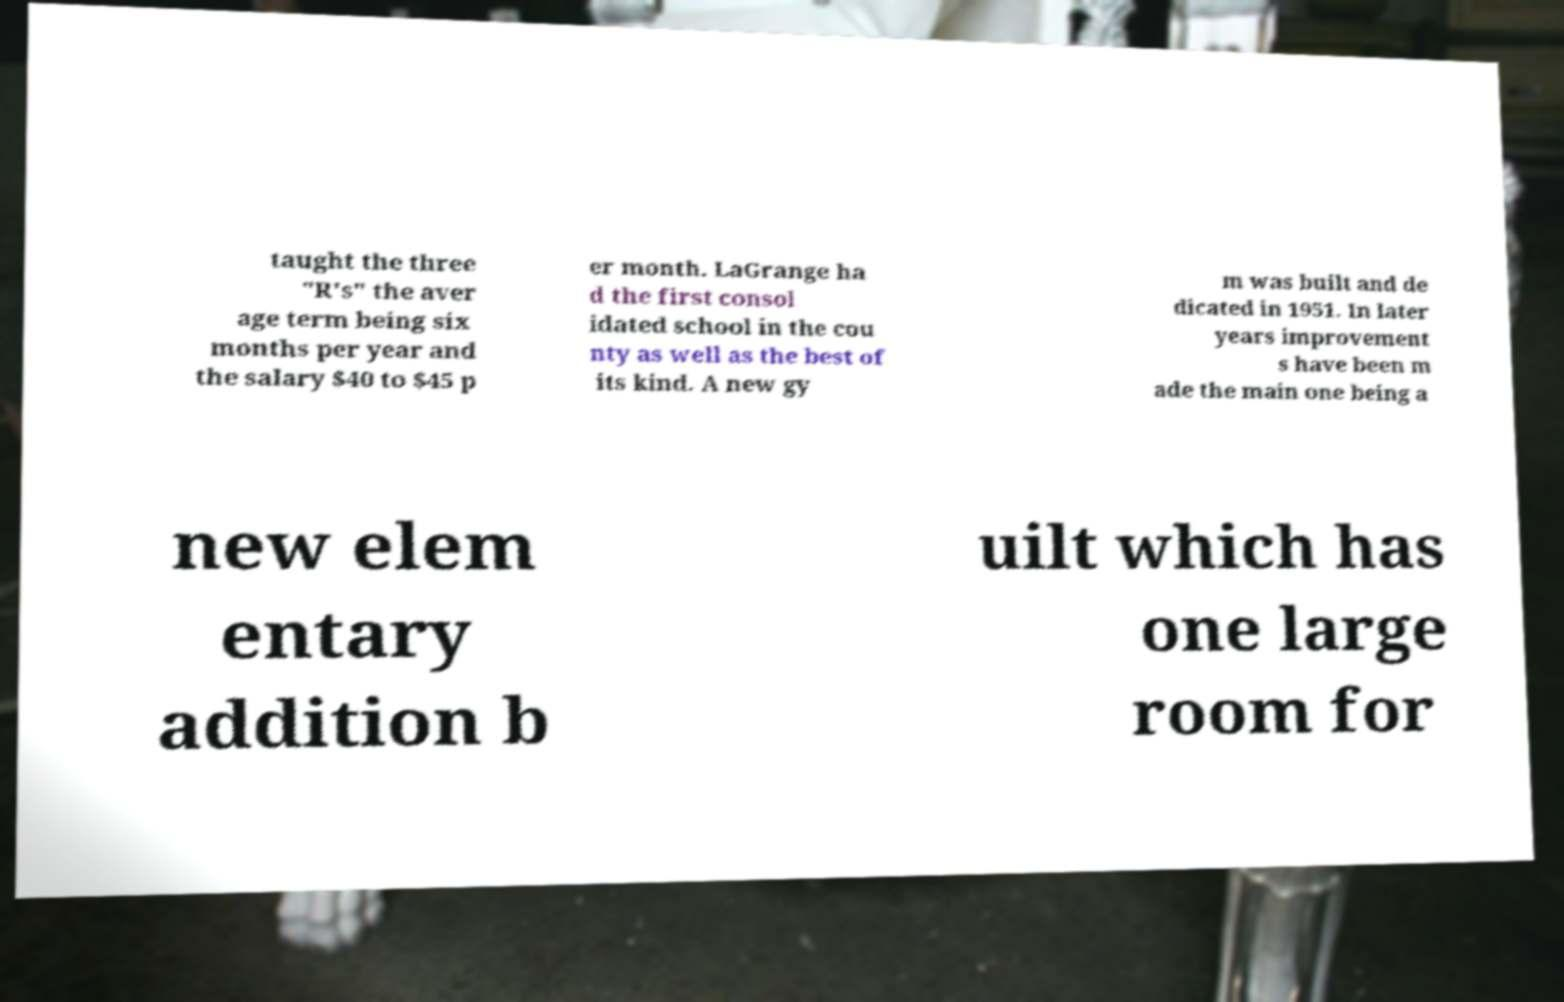Could you extract and type out the text from this image? taught the three "R's" the aver age term being six months per year and the salary $40 to $45 p er month. LaGrange ha d the first consol idated school in the cou nty as well as the best of its kind. A new gy m was built and de dicated in 1951. In later years improvement s have been m ade the main one being a new elem entary addition b uilt which has one large room for 